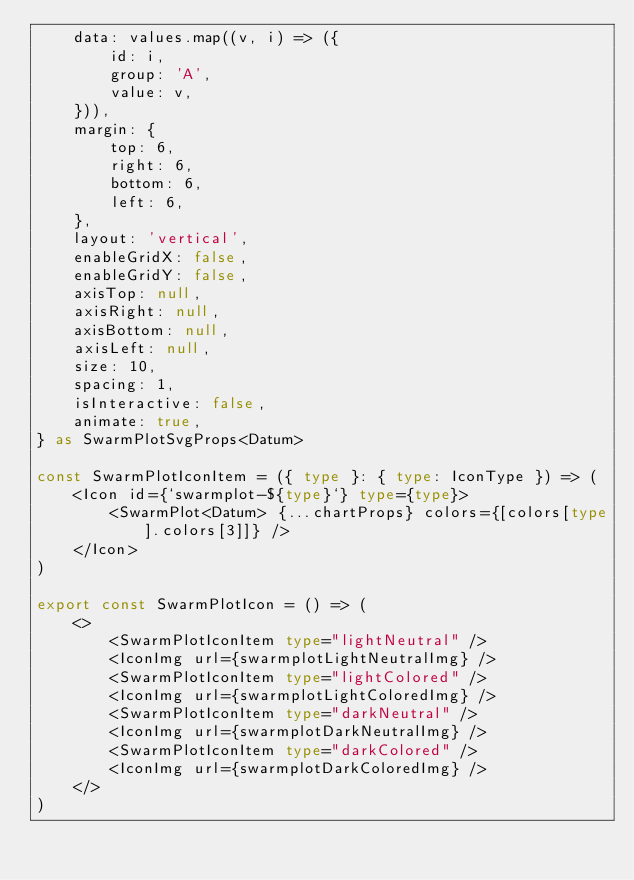Convert code to text. <code><loc_0><loc_0><loc_500><loc_500><_TypeScript_>    data: values.map((v, i) => ({
        id: i,
        group: 'A',
        value: v,
    })),
    margin: {
        top: 6,
        right: 6,
        bottom: 6,
        left: 6,
    },
    layout: 'vertical',
    enableGridX: false,
    enableGridY: false,
    axisTop: null,
    axisRight: null,
    axisBottom: null,
    axisLeft: null,
    size: 10,
    spacing: 1,
    isInteractive: false,
    animate: true,
} as SwarmPlotSvgProps<Datum>

const SwarmPlotIconItem = ({ type }: { type: IconType }) => (
    <Icon id={`swarmplot-${type}`} type={type}>
        <SwarmPlot<Datum> {...chartProps} colors={[colors[type].colors[3]]} />
    </Icon>
)

export const SwarmPlotIcon = () => (
    <>
        <SwarmPlotIconItem type="lightNeutral" />
        <IconImg url={swarmplotLightNeutralImg} />
        <SwarmPlotIconItem type="lightColored" />
        <IconImg url={swarmplotLightColoredImg} />
        <SwarmPlotIconItem type="darkNeutral" />
        <IconImg url={swarmplotDarkNeutralImg} />
        <SwarmPlotIconItem type="darkColored" />
        <IconImg url={swarmplotDarkColoredImg} />
    </>
)
</code> 